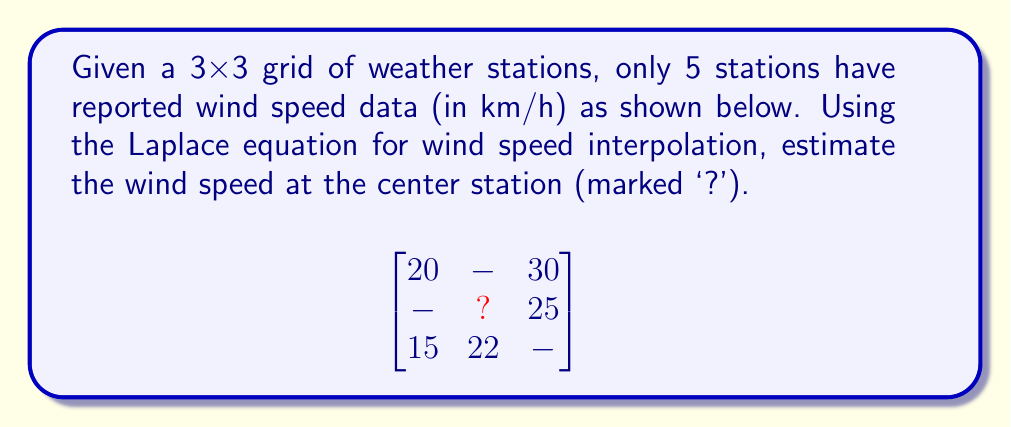Could you help me with this problem? To solve this problem, we'll use the Laplace equation for wind speed interpolation. The Laplace equation states that the value at a point is the average of its neighboring points.

Step 1: Identify the neighboring points of the center station.
The center station has four neighbors: above, below, left, and right.

Step 2: Apply the Laplace equation.
Let $x$ be the wind speed at the center station. The equation is:

$$x = \frac{1}{4}(u + d + l + r)$$

Where $u$, $d$, $l$, and $r$ are the wind speeds above, below, left, and right of the center, respectively.

Step 3: Fill in the known values.
We know the values to the right (25 km/h) and below (22 km/h). We need to estimate the values above and to the left.

Step 4: Estimate missing values using available data.
For the value above, we can use the average of the known top row: $(20 + 30) / 2 = 25$ km/h
For the value to the left, we can use the average of the known left column: $(20 + 15) / 2 = 17.5$ km/h

Step 5: Apply the Laplace equation with our estimates.
$$x = \frac{1}{4}(25 + 22 + 17.5 + 25) = \frac{89.5}{4} = 22.375$$

Therefore, the estimated wind speed at the center station is 22.375 km/h.
Answer: 22.375 km/h 